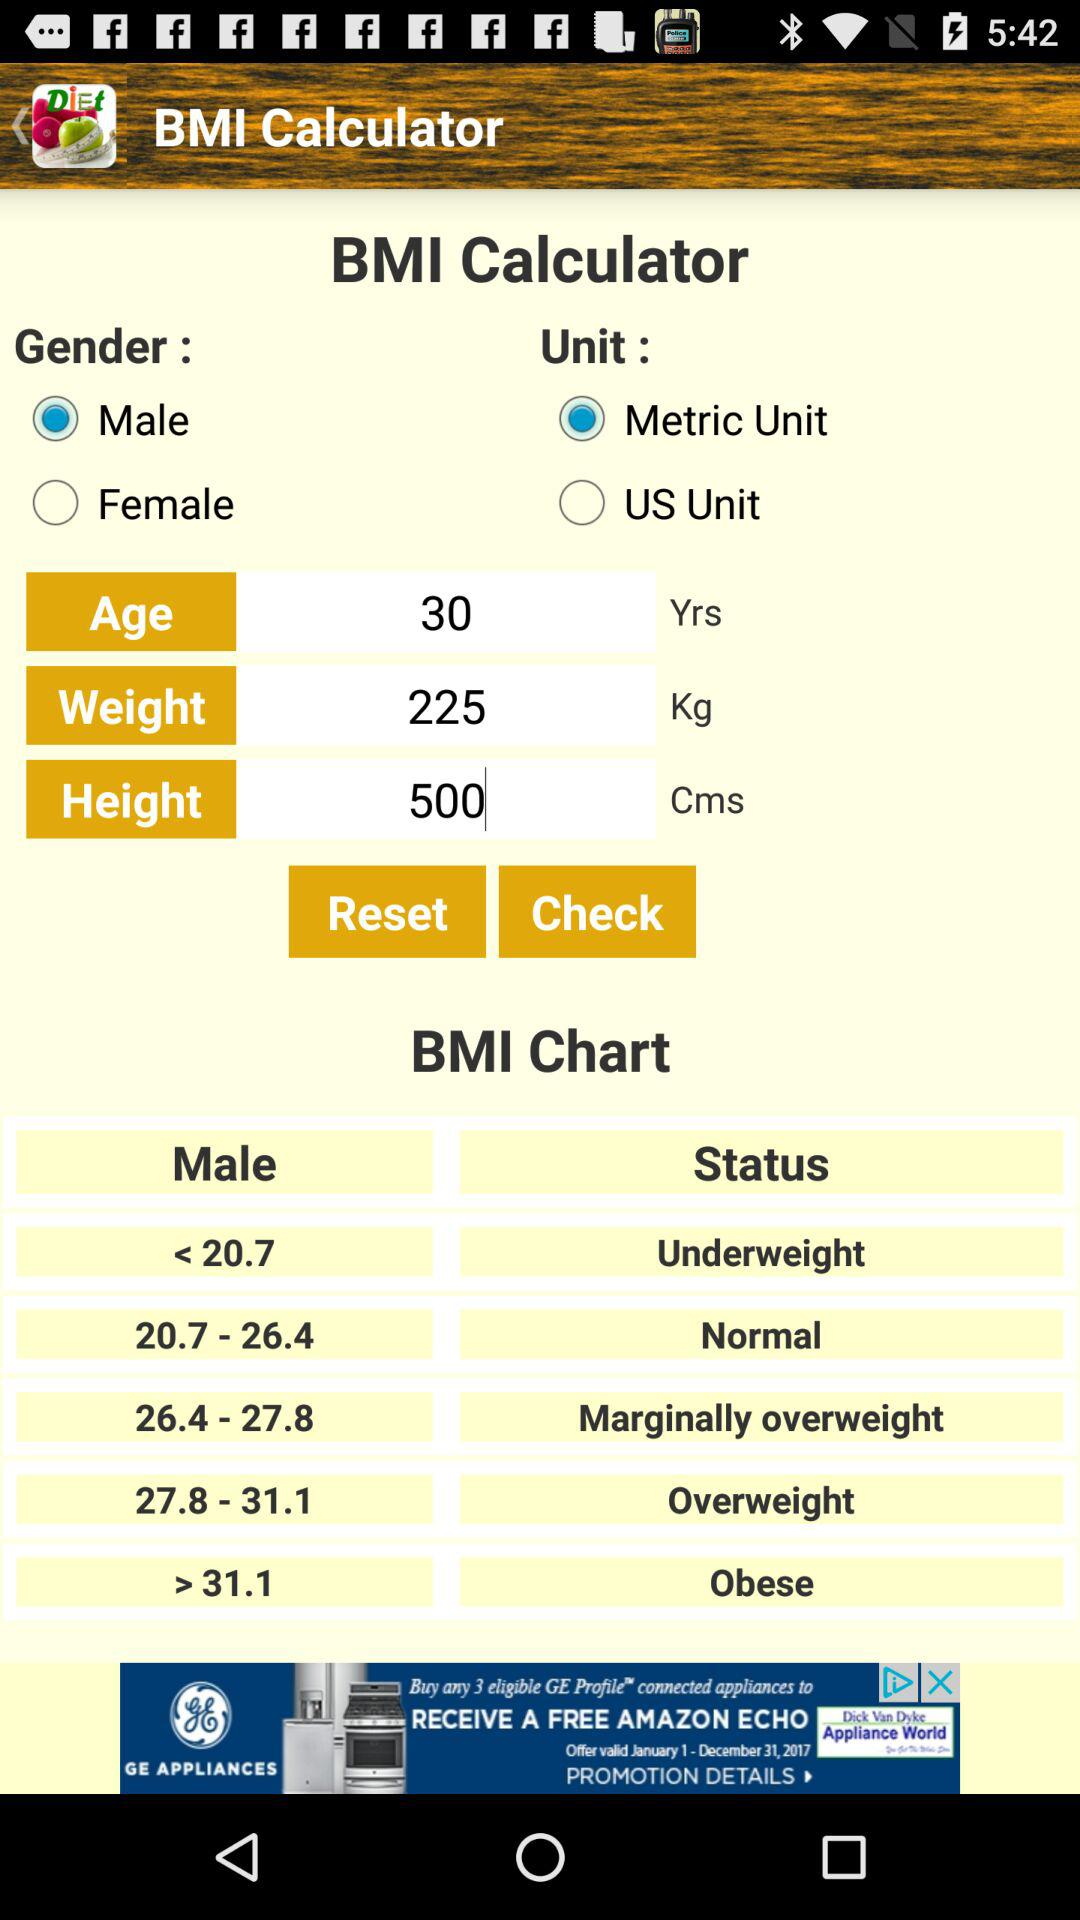What is the weight? The weight is 225 kg. 